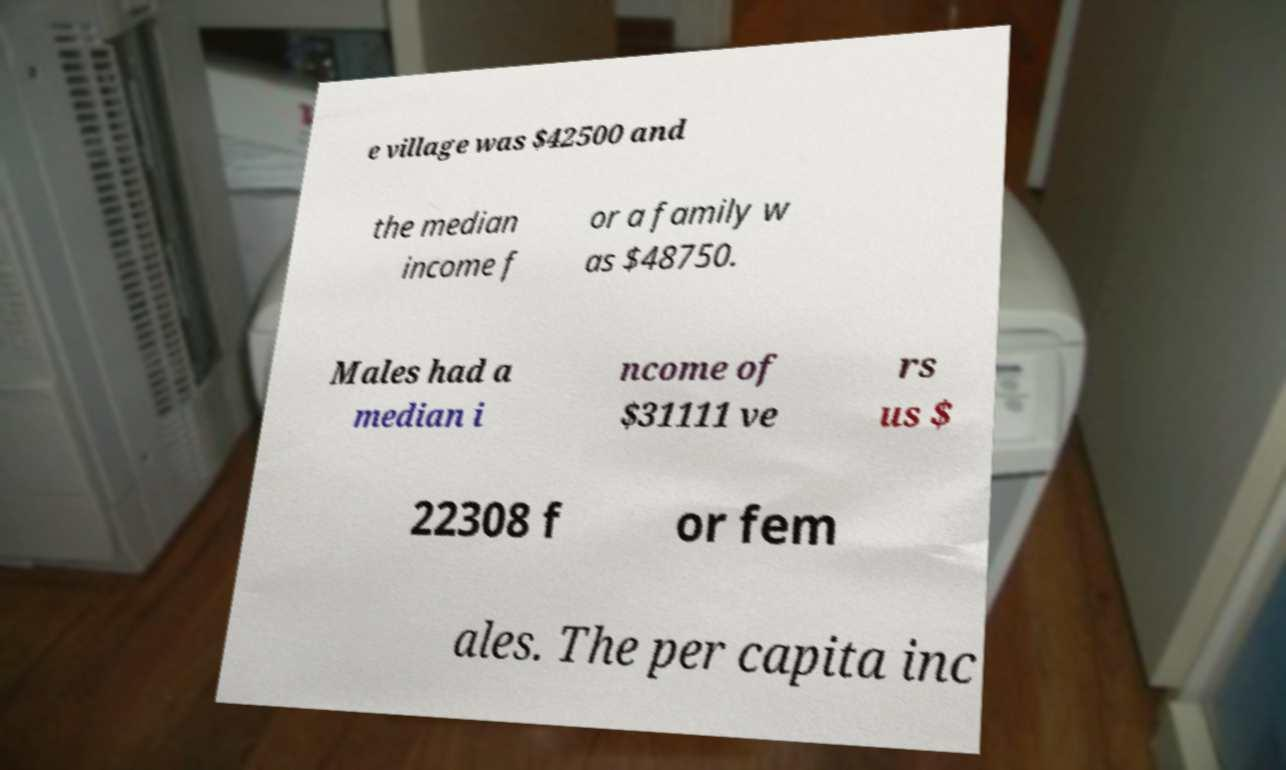Can you read and provide the text displayed in the image?This photo seems to have some interesting text. Can you extract and type it out for me? e village was $42500 and the median income f or a family w as $48750. Males had a median i ncome of $31111 ve rs us $ 22308 f or fem ales. The per capita inc 